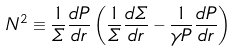<formula> <loc_0><loc_0><loc_500><loc_500>N ^ { 2 } \equiv \frac { 1 } { \varSigma } \frac { d P } { d r } \left ( \frac { 1 } { \varSigma } \frac { d \varSigma } { d r } - \frac { 1 } { \gamma P } \frac { d P } { d r } \right )</formula> 